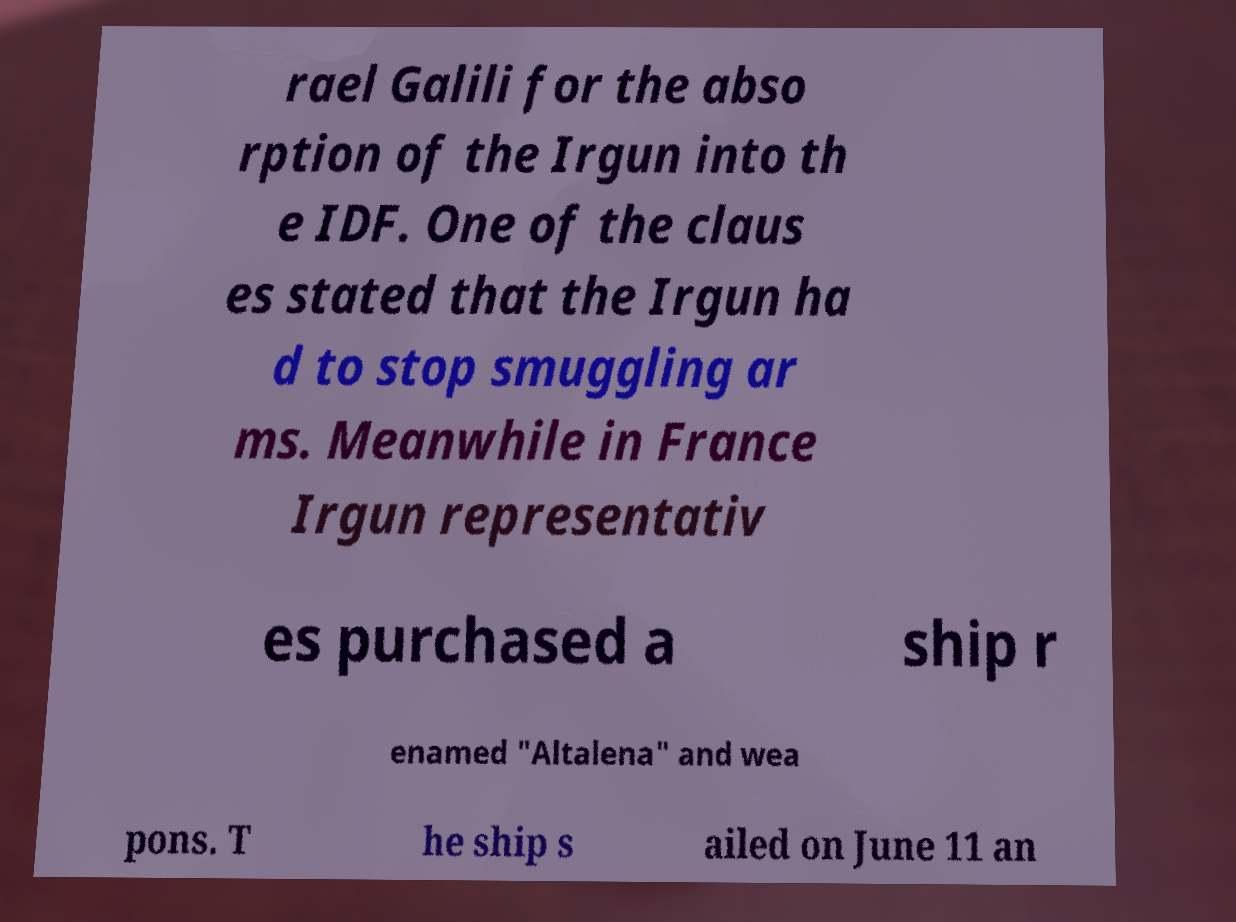There's text embedded in this image that I need extracted. Can you transcribe it verbatim? rael Galili for the abso rption of the Irgun into th e IDF. One of the claus es stated that the Irgun ha d to stop smuggling ar ms. Meanwhile in France Irgun representativ es purchased a ship r enamed "Altalena" and wea pons. T he ship s ailed on June 11 an 